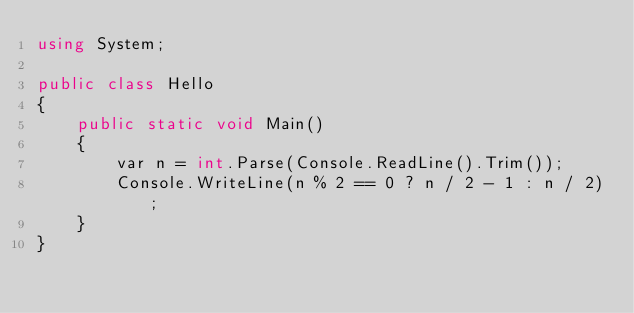Convert code to text. <code><loc_0><loc_0><loc_500><loc_500><_C#_>using System;

public class Hello
{
    public static void Main()
    {
        var n = int.Parse(Console.ReadLine().Trim());
        Console.WriteLine(n % 2 == 0 ? n / 2 - 1 : n / 2);
    }
}
</code> 